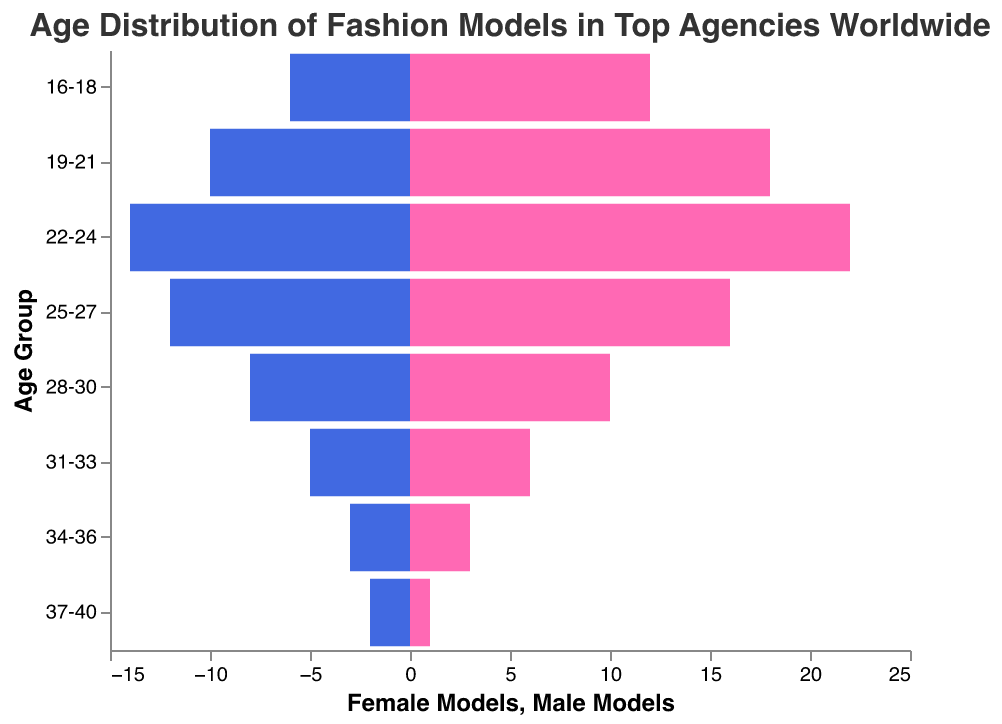what are the age groups in the population pyramid? The age groups in the population pyramid are listed on the y-axis. These age groups are "16-18", "19-21", "22-24", "25-27", "28-30", "31-33", "34-36", and "37-40".
Answer: 16-18, 19-21, 22-24, 25-27, 28-30, 31-33, 34-36, 37-40 How many female models are in the 25-27 age group? The number of female models for the 25-27 age group is given on the x-axis under the “Female Models” section. The bar for this age group shows a value of 16.
Answer: 16 Which age group has the highest number of male models? To find the age group with the highest number of male models, look at the bars extending to the left in the “Male Models” section. The age group 22-24 has the greatest negative value, representing 14 male models.
Answer: 22-24 How many models in total are there in the 22-24 age group? The total number of models in the 22-24 age group is the sum of female and male models. For this age group, there are 22 female models and 14 male models, so the total is 22 + 14.
Answer: 36 Which gender has more models in the 19-21 age group and by how much? To determine which gender has more models in the 19-21 age group, compare the heights of the bars for females and males. Females have 18 and males have 10. The difference is 18 - 10.
Answer: Females by 8 What is the sum of all female models across all age groups? To find the total number of female models, sum up the values of female models across all age groups: 12 + 18 + 22 + 16 + 10 + 6 + 3 + 1.
Answer: 88 What is the average number of male models per age group? To find the average, sum up the values of male models across all age groups and divide by the number of age groups. The sum is 6 + 10 + 14 + 12 + 8 + 5 + 3 + 2, which gives 60. Dividing by the 8 age groups, 60 / 8.
Answer: 7.5 Compare the number of male and female models in the 28-30 age group. For the 28-30 age group, the female model count is 10 and the male model count is 8. By comparing, you can see that there are more females by 10 - 8.
Answer: Females by 2 In which age group is the number of male models exactly half of the number of female models? Look for an age group where the male model count is exactly half the female count. For the 25-27 age group, there are 16 female models and 12 male models, but 12 isn't half of 16. The closest is the 16-18 age group, where there are 12 female models and 6 male models.
Answer: 16-18 